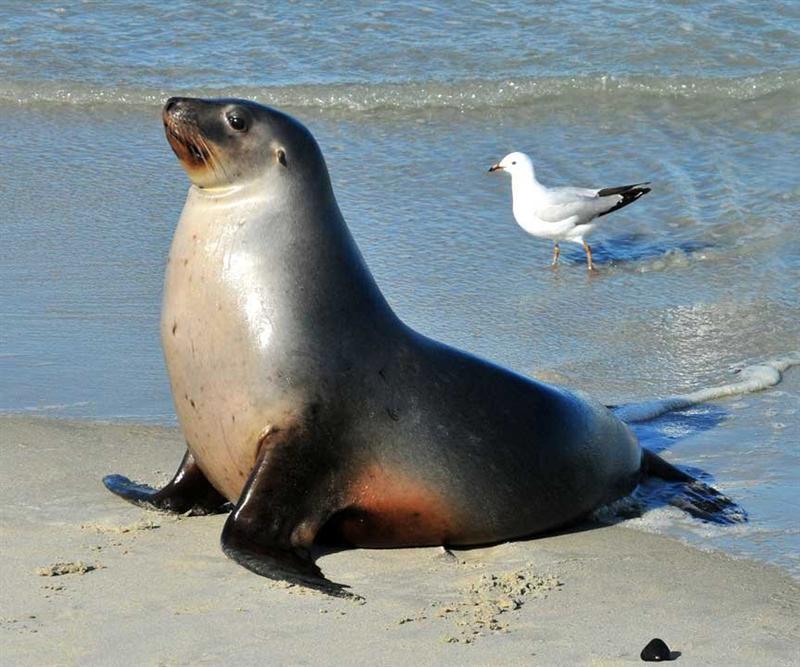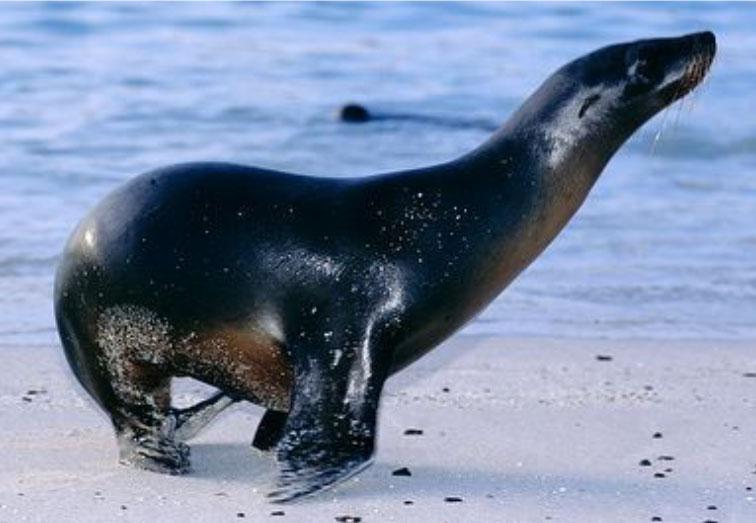The first image is the image on the left, the second image is the image on the right. Evaluate the accuracy of this statement regarding the images: "There are two seals in total.". Is it true? Answer yes or no. Yes. The first image is the image on the left, the second image is the image on the right. Given the left and right images, does the statement "An image shows exactly one seal on a manmade structure next to a blue pool." hold true? Answer yes or no. No. 